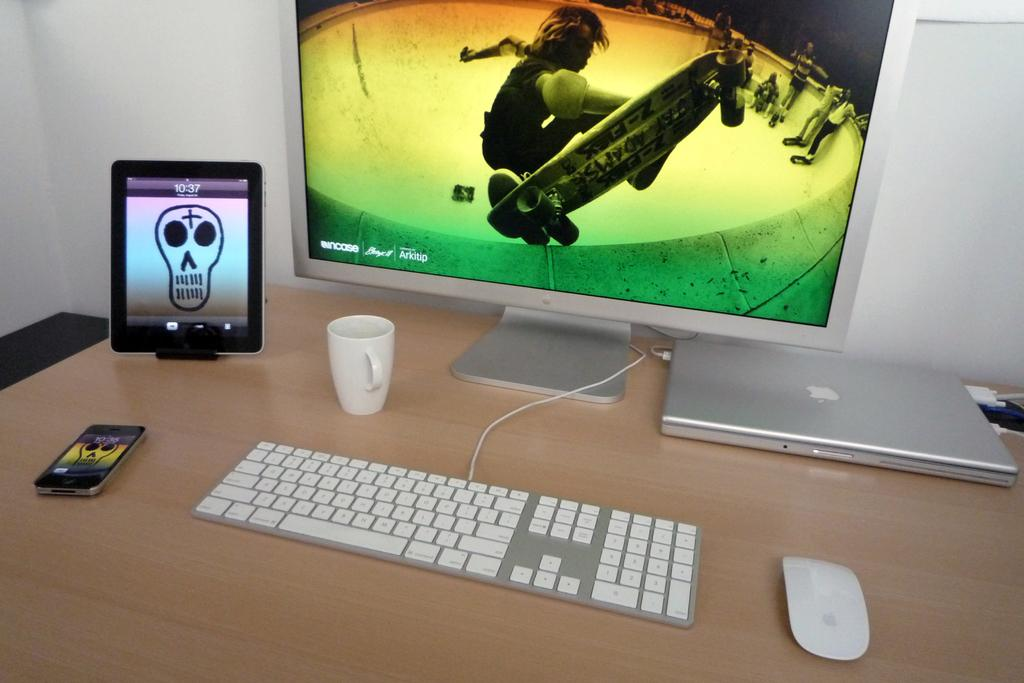<image>
Give a short and clear explanation of the subsequent image. Silver desktop with an iPad next to it that has the time at 10:37. 